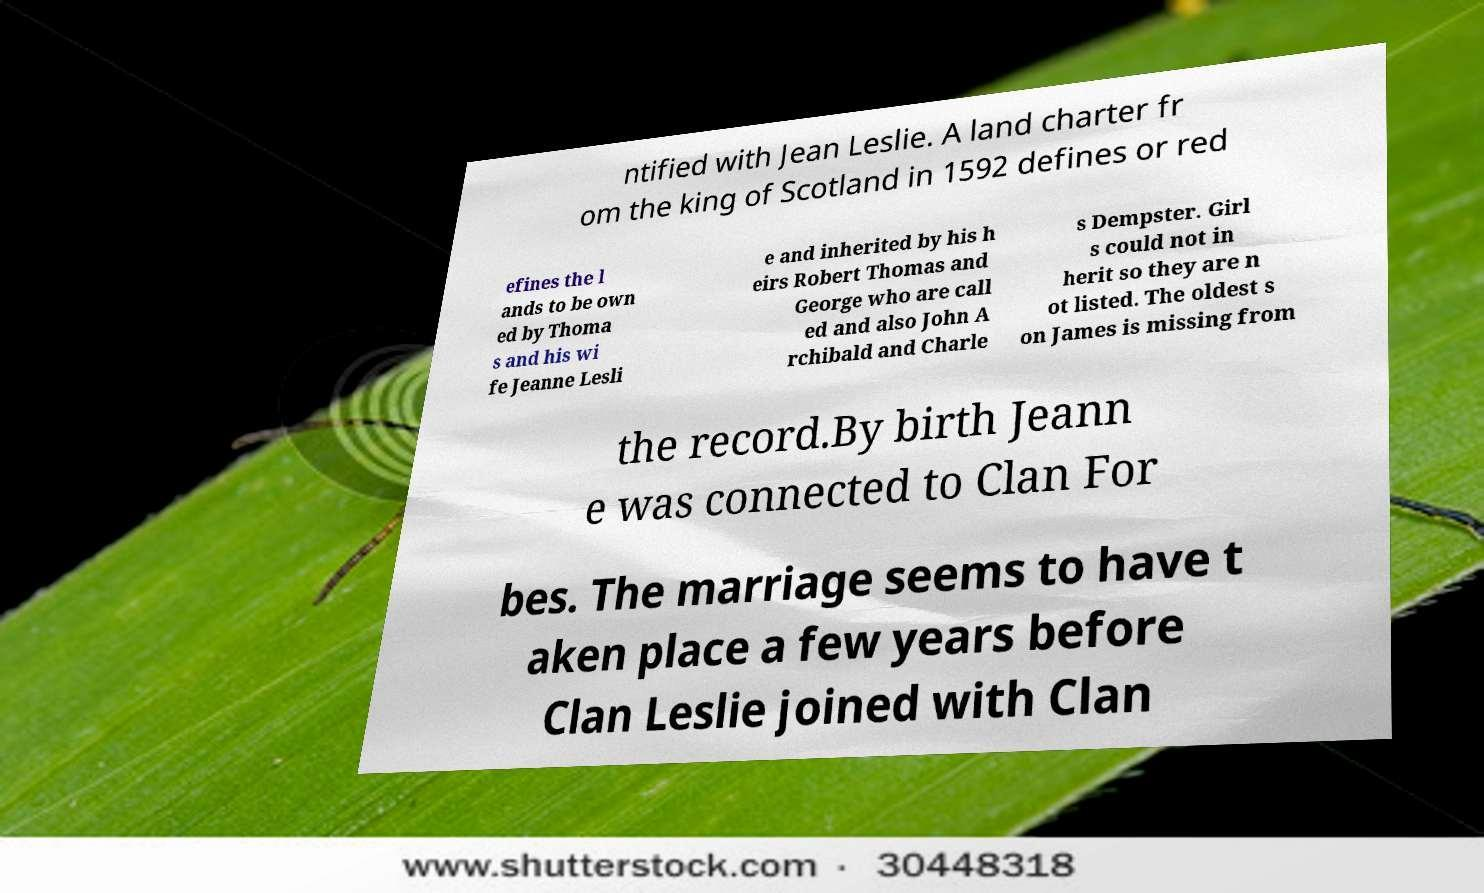Could you assist in decoding the text presented in this image and type it out clearly? ntified with Jean Leslie. A land charter fr om the king of Scotland in 1592 defines or red efines the l ands to be own ed by Thoma s and his wi fe Jeanne Lesli e and inherited by his h eirs Robert Thomas and George who are call ed and also John A rchibald and Charle s Dempster. Girl s could not in herit so they are n ot listed. The oldest s on James is missing from the record.By birth Jeann e was connected to Clan For bes. The marriage seems to have t aken place a few years before Clan Leslie joined with Clan 